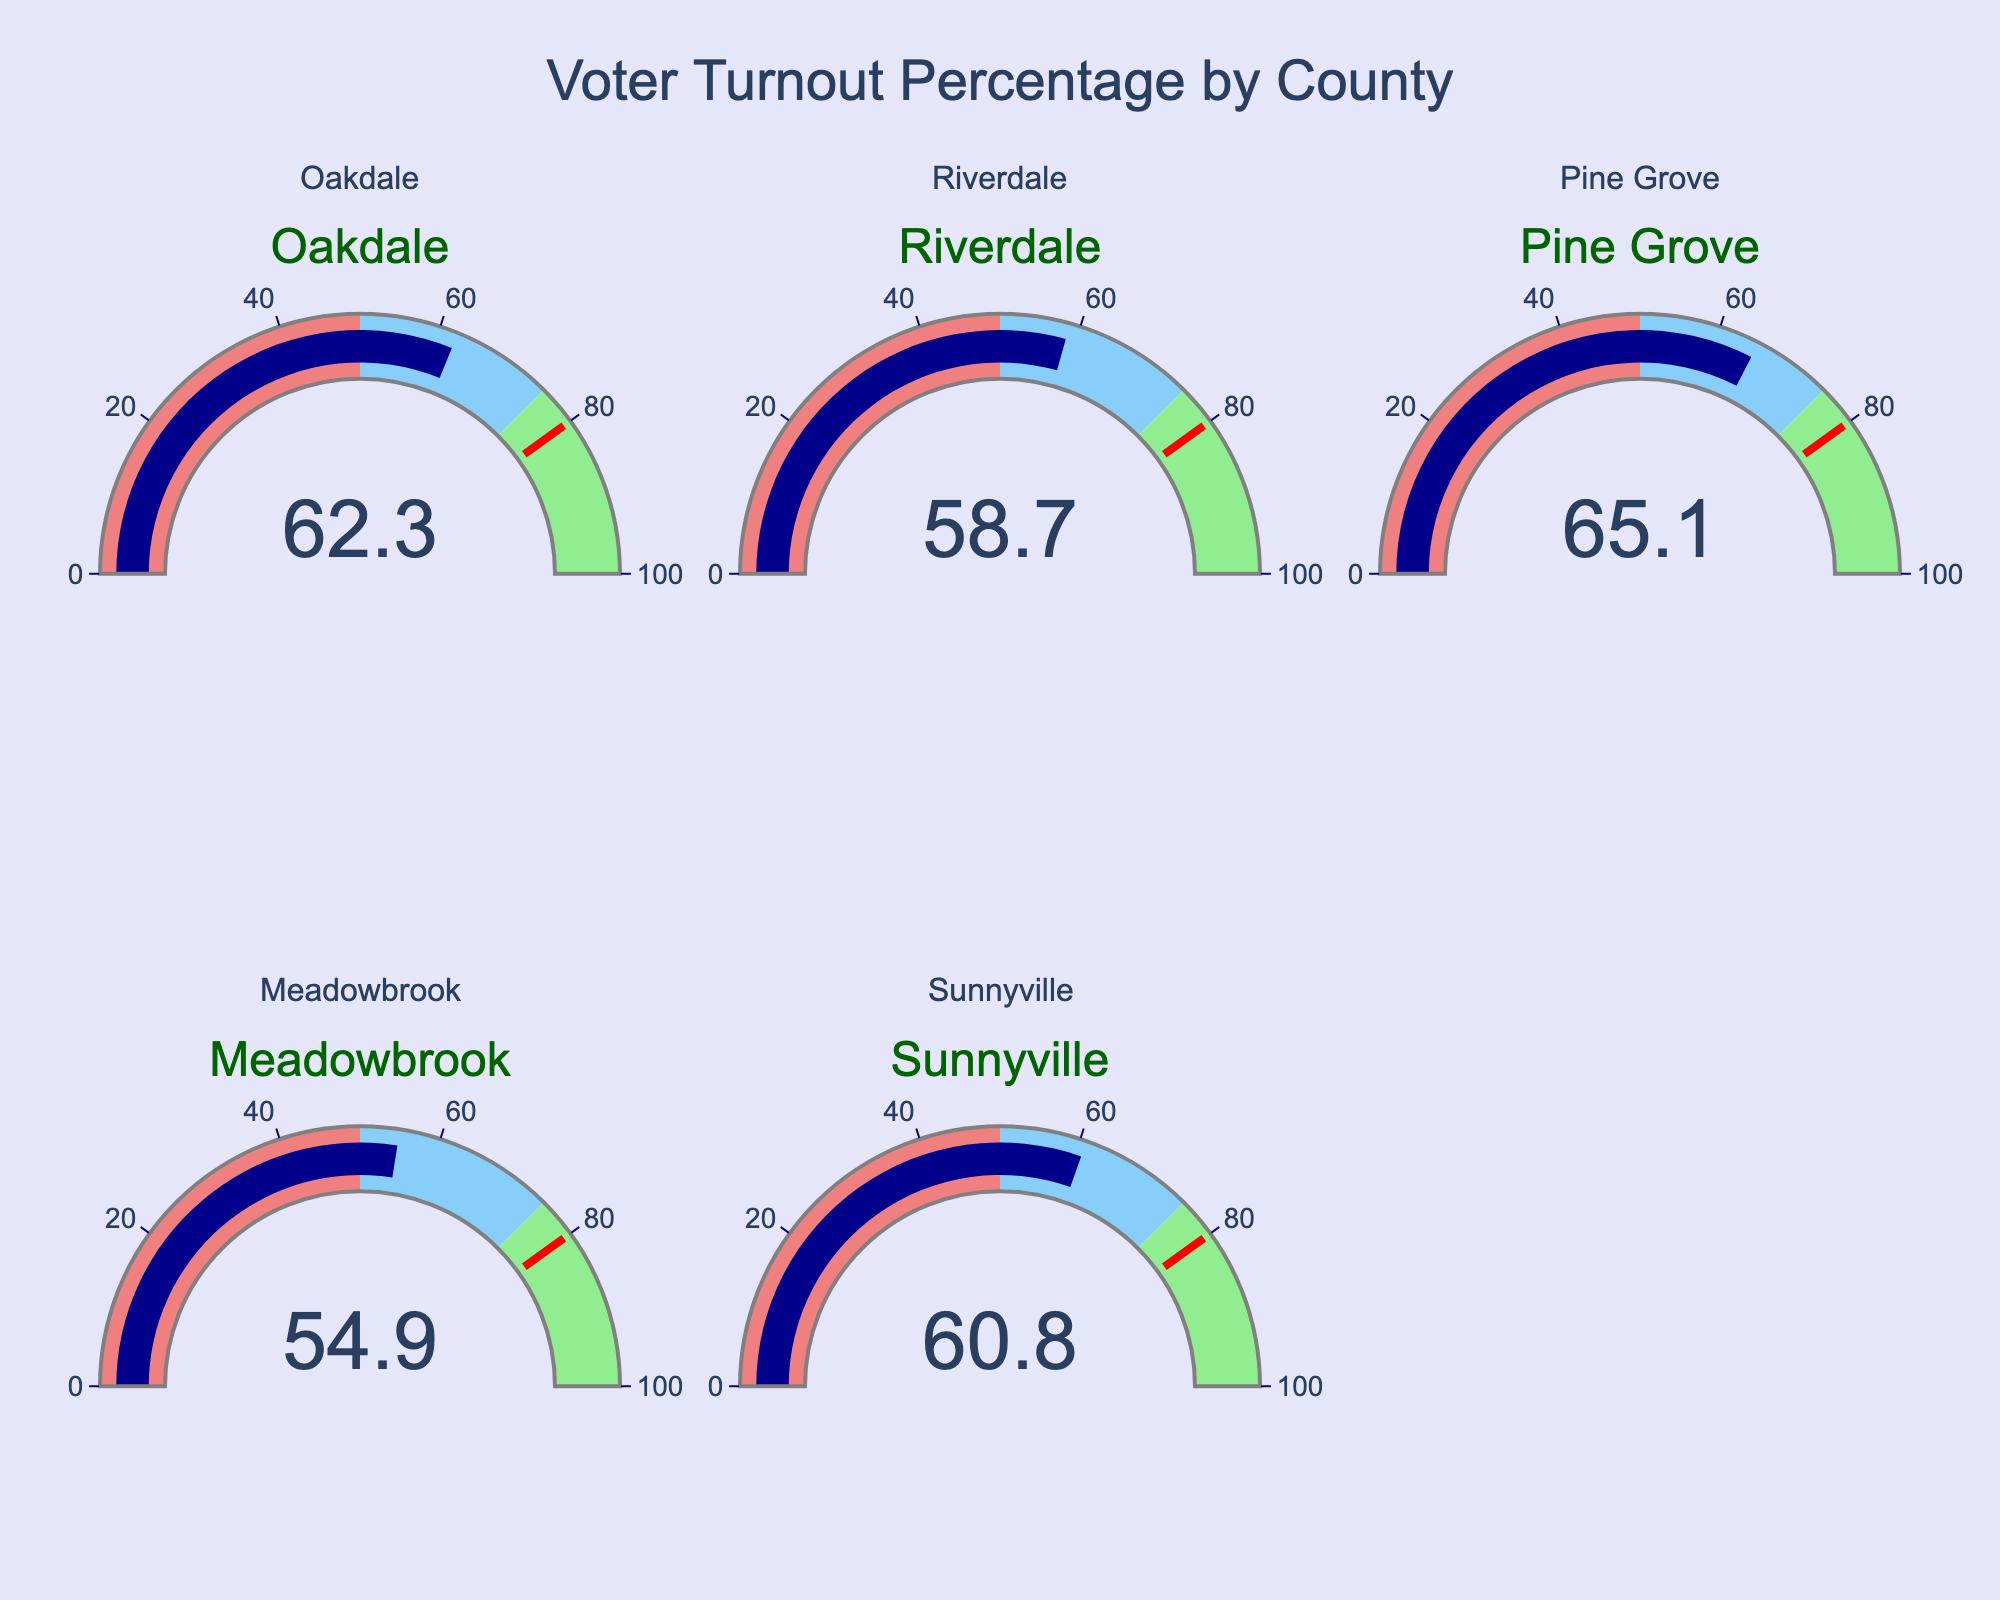What's the title of the figure? The title can be found at the top of the figure.
Answer: Voter Turnout Percentage by County How many counties are represented in the figure? There are gauges for five different counties displayed on the figure.
Answer: 5 Which county has the highest voter turnout percentage? Look for the gauge with the highest number indicated. Pine Grove shows 65.1%, which is the highest.
Answer: Pine Grove Which county has the lowest voter turnout percentage? Look for the lowest number on the gauges. Meadowbrook has the lowest percentage at 54.9%.
Answer: Meadowbrook What's the average voter turnout percentage across all counties? Sum the voter turnout percentages (62.3 + 58.7 + 65.1 + 54.9 + 60.8) and divide by the number of counties (5). (62.3 + 58.7 + 65.1 + 54.9 + 60.8) / 5 = 60.36
Answer: 60.36 Is Sunnyville's voter turnout percentage greater than Meadowbrook's? Compare the values of Sunnyville (60.8%) and Meadowbrook (54.9%).
Answer: Yes What is the difference in voter turnout percentage between Riverdale and Oakdale? Subtract Riverdale's percentage (58.7%) from Oakdale's percentage (62.3%). 62.3 - 58.7 = 3.6
Answer: 3.6 Which county's voting turnout is closest to the average voter turnout percentage? The average is 60.36%. Compare the differences of each county's voter turnout from the average. Sunnyville's turnout (60.8%) is the closest with a difference of 0.44%.
Answer: Sunnyville Are there any counties with voter turnout percentages in the red range (below 50%)? The red range on the gauge indicates percentages below 50. Examine all gauges, and none of them are in the red range.
Answer: No Have any counties met or exceeded the threshold indicated by the red line on the gauge? The threshold line is set at 80%. Examine all counties, and none of them have met or exceeded this threshold.
Answer: No 